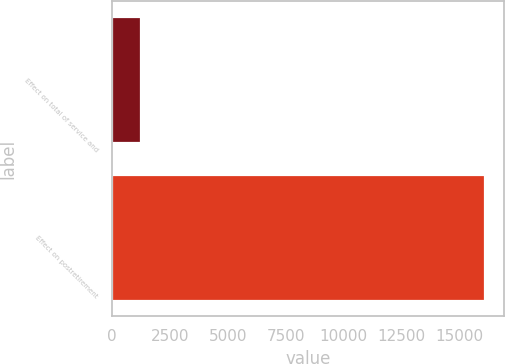Convert chart. <chart><loc_0><loc_0><loc_500><loc_500><bar_chart><fcel>Effect on total of service and<fcel>Effect on postretirement<nl><fcel>1261<fcel>16125<nl></chart> 